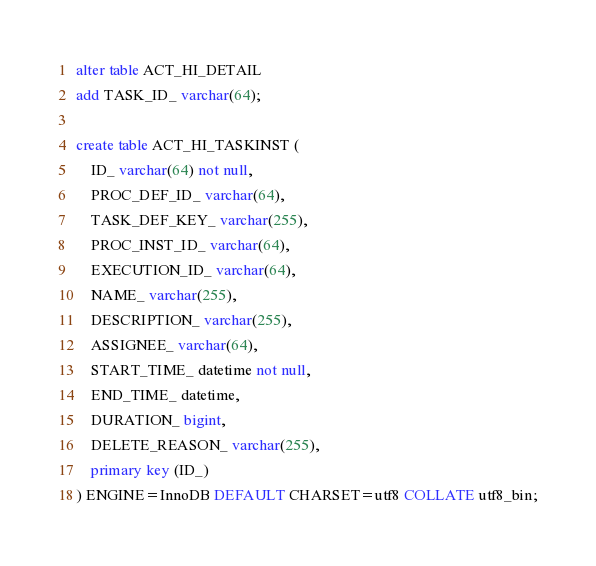<code> <loc_0><loc_0><loc_500><loc_500><_SQL_>alter table ACT_HI_DETAIL 
add TASK_ID_ varchar(64);

create table ACT_HI_TASKINST (
    ID_ varchar(64) not null,
    PROC_DEF_ID_ varchar(64),
    TASK_DEF_KEY_ varchar(255),
    PROC_INST_ID_ varchar(64),
    EXECUTION_ID_ varchar(64),
    NAME_ varchar(255),
    DESCRIPTION_ varchar(255),
    ASSIGNEE_ varchar(64),
    START_TIME_ datetime not null,
    END_TIME_ datetime,
    DURATION_ bigint,
    DELETE_REASON_ varchar(255),
    primary key (ID_)
) ENGINE=InnoDB DEFAULT CHARSET=utf8 COLLATE utf8_bin;
</code> 